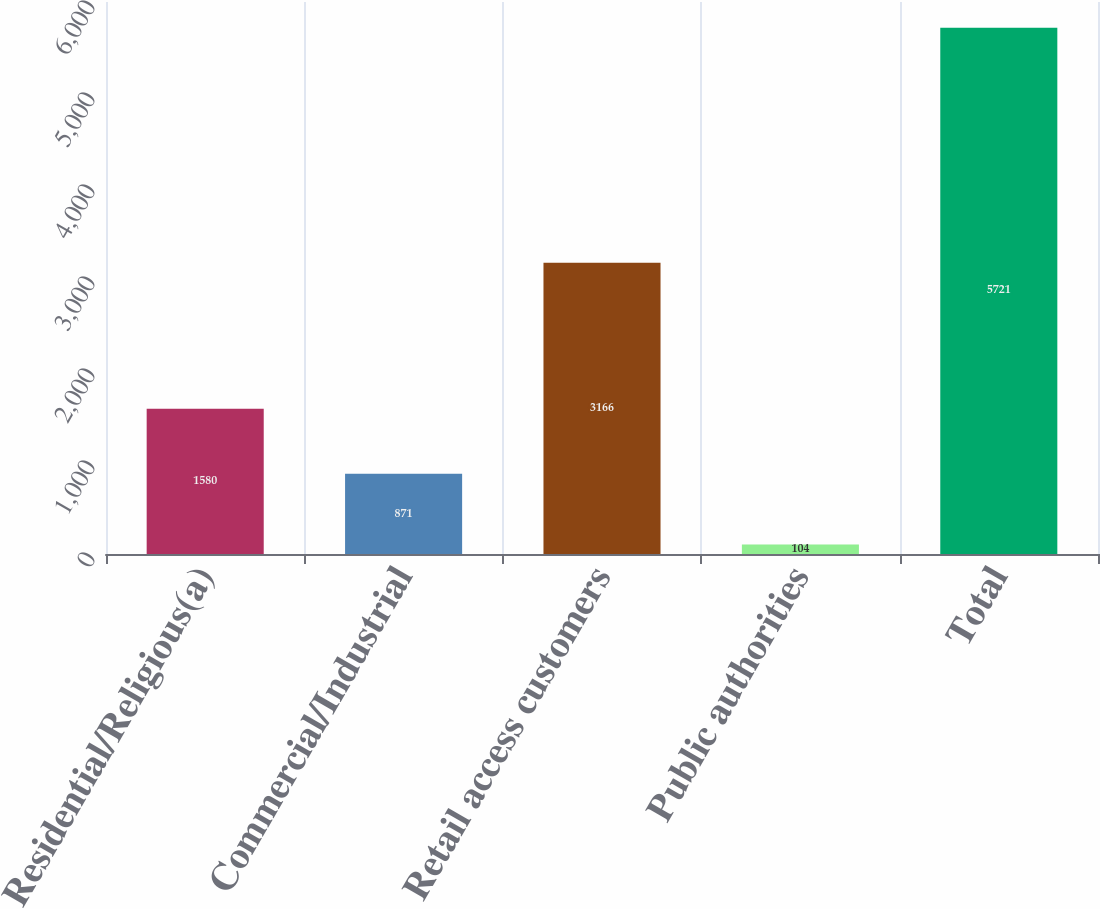<chart> <loc_0><loc_0><loc_500><loc_500><bar_chart><fcel>Residential/Religious(a)<fcel>Commercial/Industrial<fcel>Retail access customers<fcel>Public authorities<fcel>Total<nl><fcel>1580<fcel>871<fcel>3166<fcel>104<fcel>5721<nl></chart> 